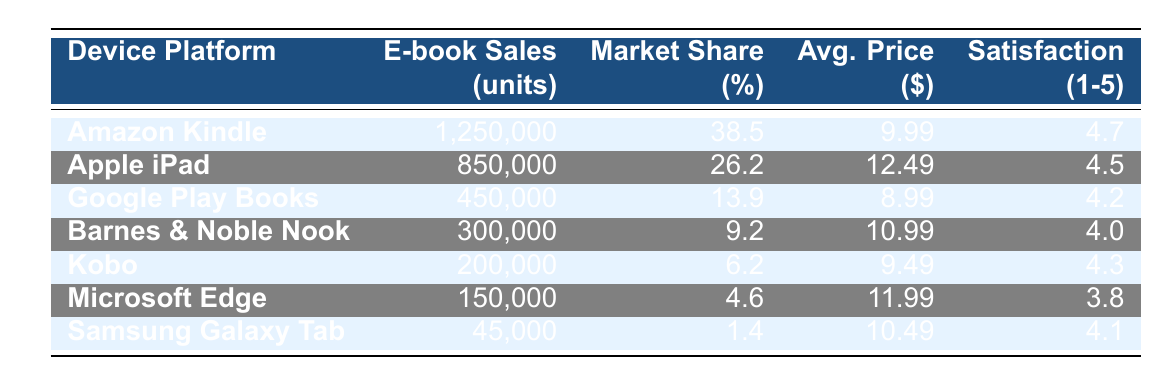What is the total number of e-book sales for all device platforms combined? To find the total e-book sales, add the sales of all the devices: 1,250,000 + 850,000 + 450,000 + 300,000 + 200,000 + 150,000 + 45,000 = 3,245,000
Answer: 3,245,000 Which device platform has the highest market share? The highest market share is listed in the table, and Amazon Kindle has a market share of 38.5%, which is greater than any other platform's market share.
Answer: Amazon Kindle What is the average customer satisfaction rating across all devices? To calculate the average customer satisfaction, sum the ratings (4.7 + 4.5 + 4.2 + 4.0 + 4.3 + 3.8 + 4.1) = 29.6 and divide by the number of platforms, which is 7. Therefore, the average is 29.6 / 7 ≈ 4.23.
Answer: 4.23 Is the average purchase price for e-books on Amazon Kindle higher than on Google Play Books? The average purchase price for Amazon Kindle is $9.99, and for Google Play Books, it is $8.99. Since $9.99 is greater than $8.99, the statement is true.
Answer: Yes How many more units were sold on Apple iPad compared to Barnes & Noble Nook? The units sold for Apple iPad is 850,000 and for Barnes & Noble Nook is 300,000. To find the difference, subtract: 850,000 - 300,000 = 550,000.
Answer: 550,000 What percentage of total e-book sales do Samsung Galaxy Tab represent? First, find the total sales: 3,245,000; now find the percentage for Samsung Galaxy Tab: (45,000 / 3,245,000) * 100 ≈ 1.39%.
Answer: 1.39% Which platform has the lowest customer satisfaction rating? Review the customer satisfaction ratings listed in the table; Microsoft Edge has the lowest rating at 3.8 out of 5.
Answer: Microsoft Edge If we combine the e-book sales of Kobo and Samsung Galaxy Tab, what is the total number of units sold? The units sold are 200,000 for Kobo and 45,000 for Samsung Galaxy Tab. Add these two figures: 200,000 + 45,000 = 245,000.
Answer: 245,000 Is the average purchase price of the Apple iPad higher than that of Microsoft Edge? The average purchase price for Apple iPad is $12.49, and for Microsoft Edge, it is $11.99. Since $12.49 is greater than $11.99, the statement is true.
Answer: Yes Which device has the second highest number of e-book sales? From the table, the second highest sales after Amazon Kindle is Apple iPad with 850,000 units sold.
Answer: Apple iPad 